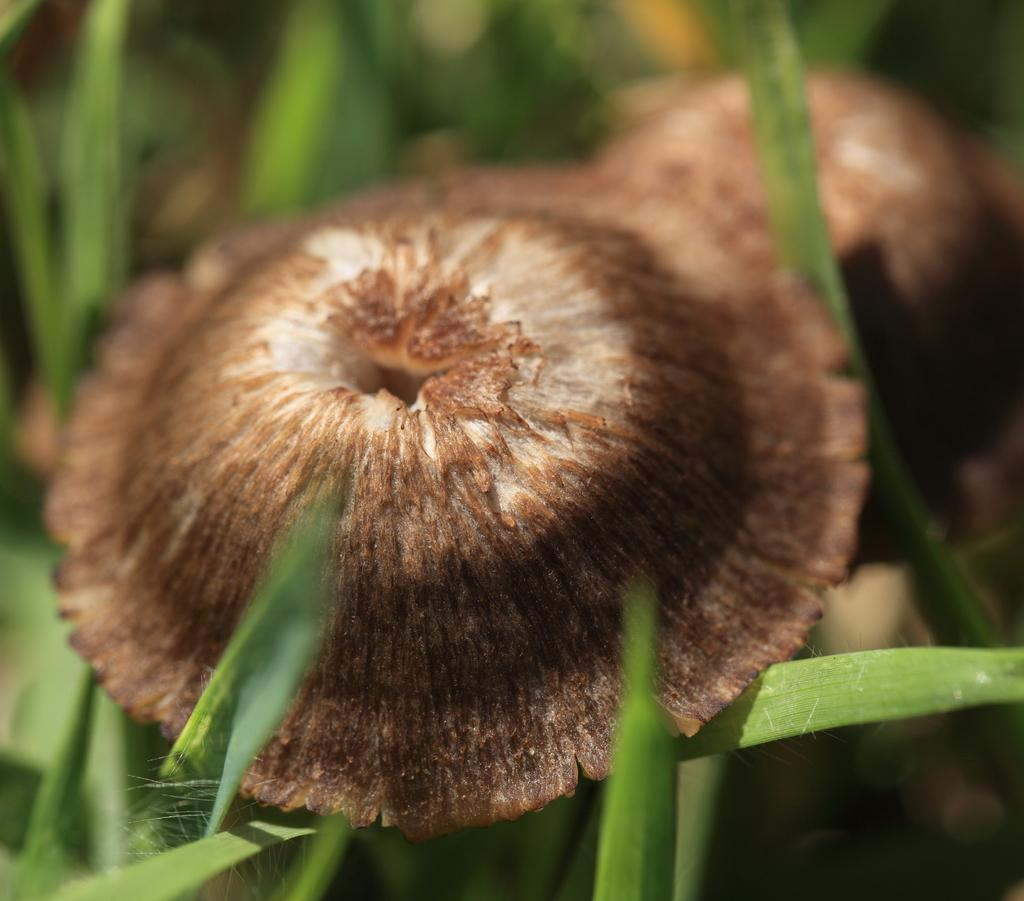What is the main subject of the image? The main subject of the image is a bud. What can be seen in the image besides the bud? There are green leaves in the image. How many firemen are present in the image? There are no firemen present in the image; it only features a bud and green leaves. 